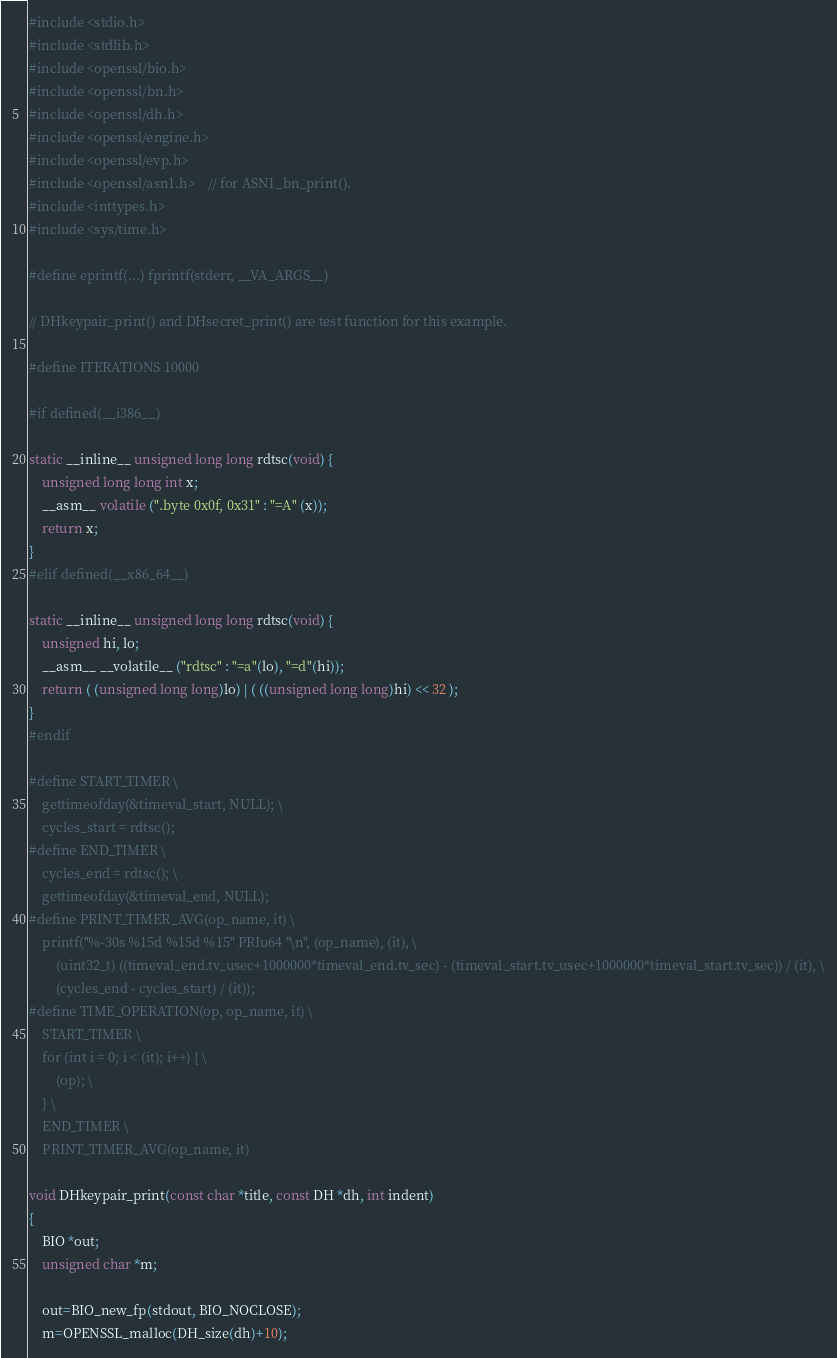<code> <loc_0><loc_0><loc_500><loc_500><_C_>#include <stdio.h>
#include <stdlib.h>
#include <openssl/bio.h>
#include <openssl/bn.h>
#include <openssl/dh.h>
#include <openssl/engine.h>
#include <openssl/evp.h>
#include <openssl/asn1.h>	// for ASN1_bn_print().
#include <inttypes.h>
#include <sys/time.h>

#define eprintf(...) fprintf(stderr, __VA_ARGS__)

// DHkeypair_print() and DHsecret_print() are test function for this example.

#define ITERATIONS 10000

#if defined(__i386__)

static __inline__ unsigned long long rdtsc(void) {
	unsigned long long int x;
	__asm__ volatile (".byte 0x0f, 0x31" : "=A" (x));
	return x;
}
#elif defined(__x86_64__)

static __inline__ unsigned long long rdtsc(void) {
	unsigned hi, lo;
	__asm__ __volatile__ ("rdtsc" : "=a"(lo), "=d"(hi));
	return ( (unsigned long long)lo) | ( ((unsigned long long)hi) << 32 );
}
#endif

#define START_TIMER \
	gettimeofday(&timeval_start, NULL); \
	cycles_start = rdtsc();
#define END_TIMER \
	cycles_end = rdtsc(); \
	gettimeofday(&timeval_end, NULL);
#define PRINT_TIMER_AVG(op_name, it) \
	printf("%-30s %15d %15d %15" PRIu64 "\n", (op_name), (it), \
		(uint32_t) ((timeval_end.tv_usec+1000000*timeval_end.tv_sec) - (timeval_start.tv_usec+1000000*timeval_start.tv_sec)) / (it), \
		(cycles_end - cycles_start) / (it));
#define TIME_OPERATION(op, op_name, it) \
	START_TIMER \
	for (int i = 0; i < (it); i++) { \
		(op); \
	} \
	END_TIMER \
	PRINT_TIMER_AVG(op_name, it)

void DHkeypair_print(const char *title, const DH *dh, int indent)
{
	BIO *out;
	unsigned char *m;

	out=BIO_new_fp(stdout, BIO_NOCLOSE);
	m=OPENSSL_malloc(DH_size(dh)+10);
</code> 